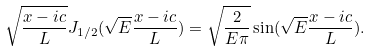Convert formula to latex. <formula><loc_0><loc_0><loc_500><loc_500>\sqrt { \frac { x - i c } { L } } J _ { 1 / 2 } ( \sqrt { E } \frac { x - i c } { L } ) = \sqrt { \frac { 2 } { E \pi } } \sin ( \sqrt { E } \frac { x - i c } { L } ) .</formula> 